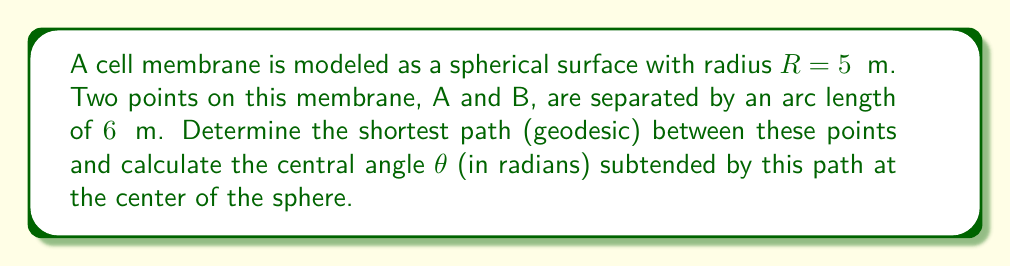Provide a solution to this math problem. To solve this problem, we'll follow these steps:

1) On a sphere, the shortest path between two points (geodesic) is always along a great circle.

2) The arc length $s$ of a great circle is related to the radius $R$ and the central angle $\theta$ (in radians) by the formula:

   $$s = R\theta$$

3) We're given:
   - Radius $R = 5$ μm
   - Arc length $s = 6$ μm

4) Substituting these values into the formula:

   $$6 = 5\theta$$

5) Solving for $\theta$:

   $$\theta = \frac{6}{5} = 1.2$$

6) Therefore, the central angle is 1.2 radians.

The geodesic path between the two points is the arc of the great circle connecting them, which subtends this central angle.
Answer: $\theta = 1.2$ radians 